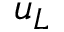Convert formula to latex. <formula><loc_0><loc_0><loc_500><loc_500>u _ { L }</formula> 